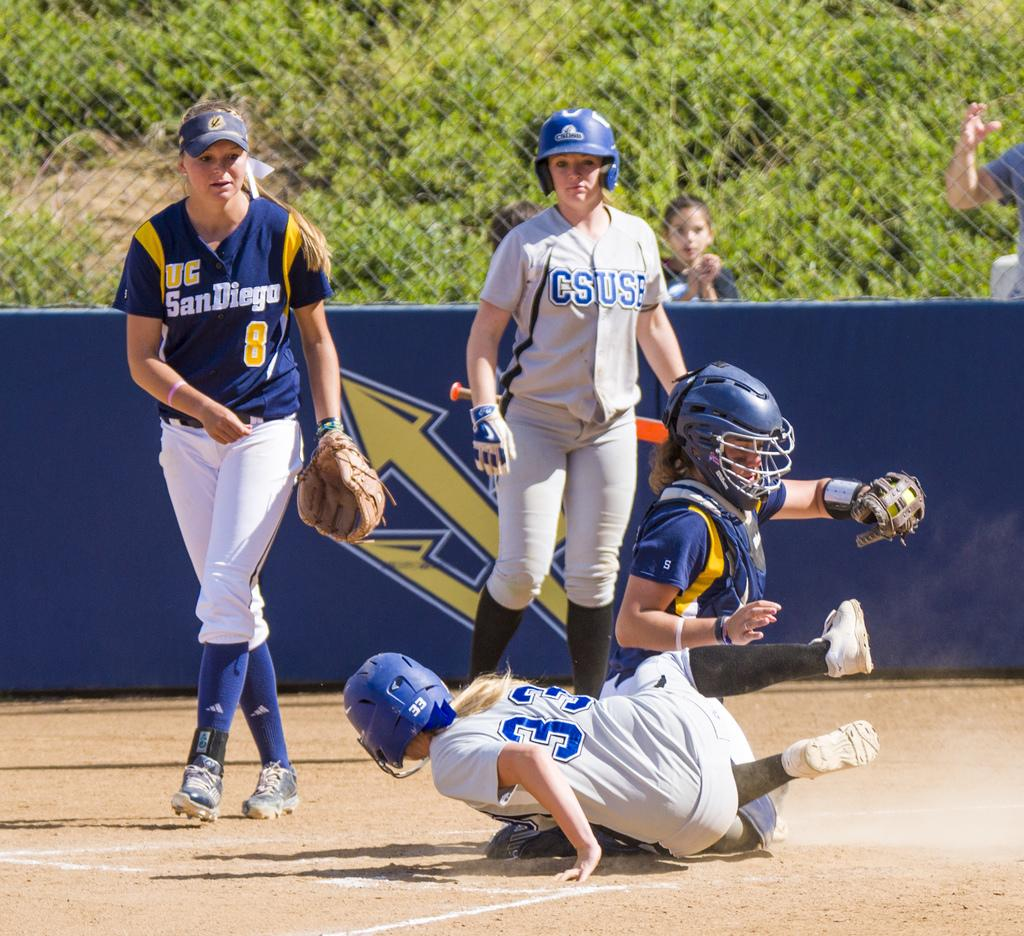Provide a one-sentence caption for the provided image. A girls' baseball game involves two competing college teams, one from UC San Diego and the other from Cal State University San Bernardino. 